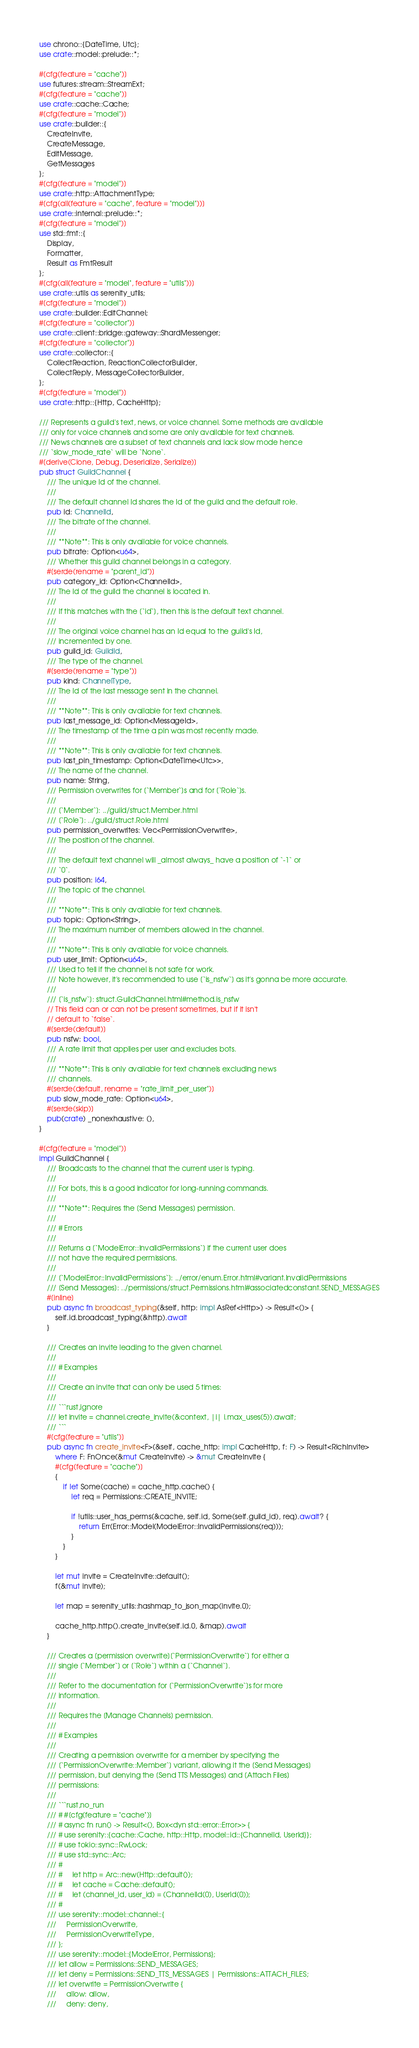<code> <loc_0><loc_0><loc_500><loc_500><_Rust_>use chrono::{DateTime, Utc};
use crate::model::prelude::*;

#[cfg(feature = "cache")]
use futures::stream::StreamExt;
#[cfg(feature = "cache")]
use crate::cache::Cache;
#[cfg(feature = "model")]
use crate::builder::{
    CreateInvite,
    CreateMessage,
    EditMessage,
    GetMessages
};
#[cfg(feature = "model")]
use crate::http::AttachmentType;
#[cfg(all(feature = "cache", feature = "model"))]
use crate::internal::prelude::*;
#[cfg(feature = "model")]
use std::fmt::{
    Display,
    Formatter,
    Result as FmtResult
};
#[cfg(all(feature = "model", feature = "utils"))]
use crate::utils as serenity_utils;
#[cfg(feature = "model")]
use crate::builder::EditChannel;
#[cfg(feature = "collector")]
use crate::client::bridge::gateway::ShardMessenger;
#[cfg(feature = "collector")]
use crate::collector::{
    CollectReaction, ReactionCollectorBuilder,
    CollectReply, MessageCollectorBuilder,
};
#[cfg(feature = "model")]
use crate::http::{Http, CacheHttp};

/// Represents a guild's text, news, or voice channel. Some methods are available
/// only for voice channels and some are only available for text channels.
/// News channels are a subset of text channels and lack slow mode hence
/// `slow_mode_rate` will be `None`.
#[derive(Clone, Debug, Deserialize, Serialize)]
pub struct GuildChannel {
    /// The unique Id of the channel.
    ///
    /// The default channel Id shares the Id of the guild and the default role.
    pub id: ChannelId,
    /// The bitrate of the channel.
    ///
    /// **Note**: This is only available for voice channels.
    pub bitrate: Option<u64>,
    /// Whether this guild channel belongs in a category.
    #[serde(rename = "parent_id")]
    pub category_id: Option<ChannelId>,
    /// The Id of the guild the channel is located in.
    ///
    /// If this matches with the [`id`], then this is the default text channel.
    ///
    /// The original voice channel has an Id equal to the guild's Id,
    /// incremented by one.
    pub guild_id: GuildId,
    /// The type of the channel.
    #[serde(rename = "type")]
    pub kind: ChannelType,
    /// The Id of the last message sent in the channel.
    ///
    /// **Note**: This is only available for text channels.
    pub last_message_id: Option<MessageId>,
    /// The timestamp of the time a pin was most recently made.
    ///
    /// **Note**: This is only available for text channels.
    pub last_pin_timestamp: Option<DateTime<Utc>>,
    /// The name of the channel.
    pub name: String,
    /// Permission overwrites for [`Member`]s and for [`Role`]s.
    ///
    /// [`Member`]: ../guild/struct.Member.html
    /// [`Role`]: ../guild/struct.Role.html
    pub permission_overwrites: Vec<PermissionOverwrite>,
    /// The position of the channel.
    ///
    /// The default text channel will _almost always_ have a position of `-1` or
    /// `0`.
    pub position: i64,
    /// The topic of the channel.
    ///
    /// **Note**: This is only available for text channels.
    pub topic: Option<String>,
    /// The maximum number of members allowed in the channel.
    ///
    /// **Note**: This is only available for voice channels.
    pub user_limit: Option<u64>,
    /// Used to tell if the channel is not safe for work.
    /// Note however, it's recommended to use [`is_nsfw`] as it's gonna be more accurate.
    ///
    /// [`is_nsfw`]: struct.GuildChannel.html#method.is_nsfw
    // This field can or can not be present sometimes, but if it isn't
    // default to `false`.
    #[serde(default)]
    pub nsfw: bool,
    /// A rate limit that applies per user and excludes bots.
    ///
    /// **Note**: This is only available for text channels excluding news
    /// channels.
    #[serde(default, rename = "rate_limit_per_user")]
    pub slow_mode_rate: Option<u64>,
    #[serde(skip)]
    pub(crate) _nonexhaustive: (),
}

#[cfg(feature = "model")]
impl GuildChannel {
    /// Broadcasts to the channel that the current user is typing.
    ///
    /// For bots, this is a good indicator for long-running commands.
    ///
    /// **Note**: Requires the [Send Messages] permission.
    ///
    /// # Errors
    ///
    /// Returns a [`ModelError::InvalidPermissions`] if the current user does
    /// not have the required permissions.
    ///
    /// [`ModelError::InvalidPermissions`]: ../error/enum.Error.html#variant.InvalidPermissions
    /// [Send Messages]: ../permissions/struct.Permissions.html#associatedconstant.SEND_MESSAGES
    #[inline]
    pub async fn broadcast_typing(&self, http: impl AsRef<Http>) -> Result<()> {
        self.id.broadcast_typing(&http).await
    }

    /// Creates an invite leading to the given channel.
    ///
    /// # Examples
    ///
    /// Create an invite that can only be used 5 times:
    ///
    /// ```rust,ignore
    /// let invite = channel.create_invite(&context, |i| i.max_uses(5)).await;
    /// ```
    #[cfg(feature = "utils")]
    pub async fn create_invite<F>(&self, cache_http: impl CacheHttp, f: F) -> Result<RichInvite>
        where F: FnOnce(&mut CreateInvite) -> &mut CreateInvite {
        #[cfg(feature = "cache")]
        {
            if let Some(cache) = cache_http.cache() {
                let req = Permissions::CREATE_INVITE;

                if !utils::user_has_perms(&cache, self.id, Some(self.guild_id), req).await? {
                    return Err(Error::Model(ModelError::InvalidPermissions(req)));
                }
            }
        }

        let mut invite = CreateInvite::default();
        f(&mut invite);

        let map = serenity_utils::hashmap_to_json_map(invite.0);

        cache_http.http().create_invite(self.id.0, &map).await
    }

    /// Creates a [permission overwrite][`PermissionOverwrite`] for either a
    /// single [`Member`] or [`Role`] within a [`Channel`].
    ///
    /// Refer to the documentation for [`PermissionOverwrite`]s for more
    /// information.
    ///
    /// Requires the [Manage Channels] permission.
    ///
    /// # Examples
    ///
    /// Creating a permission overwrite for a member by specifying the
    /// [`PermissionOverwrite::Member`] variant, allowing it the [Send Messages]
    /// permission, but denying the [Send TTS Messages] and [Attach Files]
    /// permissions:
    ///
    /// ```rust,no_run
    /// # #[cfg(feature = "cache")]
    /// # async fn run() -> Result<(), Box<dyn std::error::Error>> {
    /// # use serenity::{cache::Cache, http::Http, model::id::{ChannelId, UserId}};
    /// # use tokio::sync::RwLock;
    /// # use std::sync::Arc;
    /// #
    /// #     let http = Arc::new(Http::default());
    /// #     let cache = Cache::default();
    /// #     let (channel_id, user_id) = (ChannelId(0), UserId(0));
    /// #
    /// use serenity::model::channel::{
    ///     PermissionOverwrite,
    ///     PermissionOverwriteType,
    /// };
    /// use serenity::model::{ModelError, Permissions};
    /// let allow = Permissions::SEND_MESSAGES;
    /// let deny = Permissions::SEND_TTS_MESSAGES | Permissions::ATTACH_FILES;
    /// let overwrite = PermissionOverwrite {
    ///     allow: allow,
    ///     deny: deny,</code> 